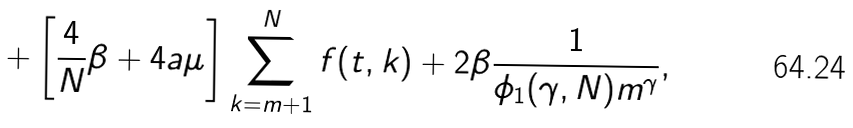<formula> <loc_0><loc_0><loc_500><loc_500>+ \left [ \frac { 4 } { N } \beta + 4 a \mu \right ] \sum _ { k = m + 1 } ^ { N } f ( t , k ) + 2 \beta \frac { 1 } { \phi _ { 1 } ( \gamma , N ) m ^ { \gamma } } ,</formula> 